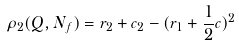<formula> <loc_0><loc_0><loc_500><loc_500>\rho _ { 2 } ( Q , N _ { f } ) = r _ { 2 } + c _ { 2 } - ( r _ { 1 } + \frac { 1 } { 2 } c ) ^ { 2 }</formula> 